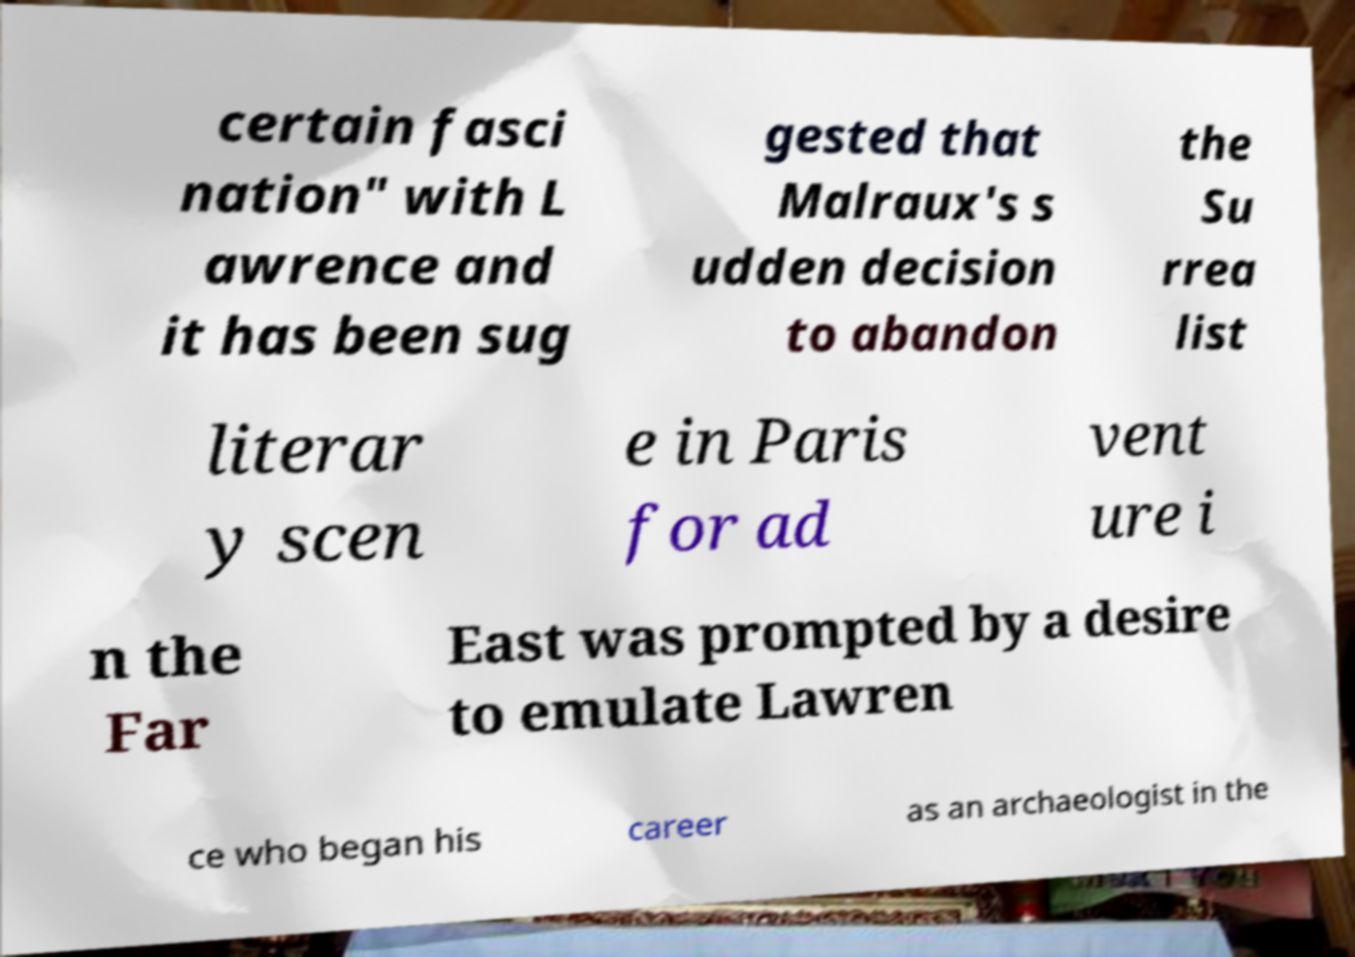Can you read and provide the text displayed in the image?This photo seems to have some interesting text. Can you extract and type it out for me? certain fasci nation" with L awrence and it has been sug gested that Malraux's s udden decision to abandon the Su rrea list literar y scen e in Paris for ad vent ure i n the Far East was prompted by a desire to emulate Lawren ce who began his career as an archaeologist in the 